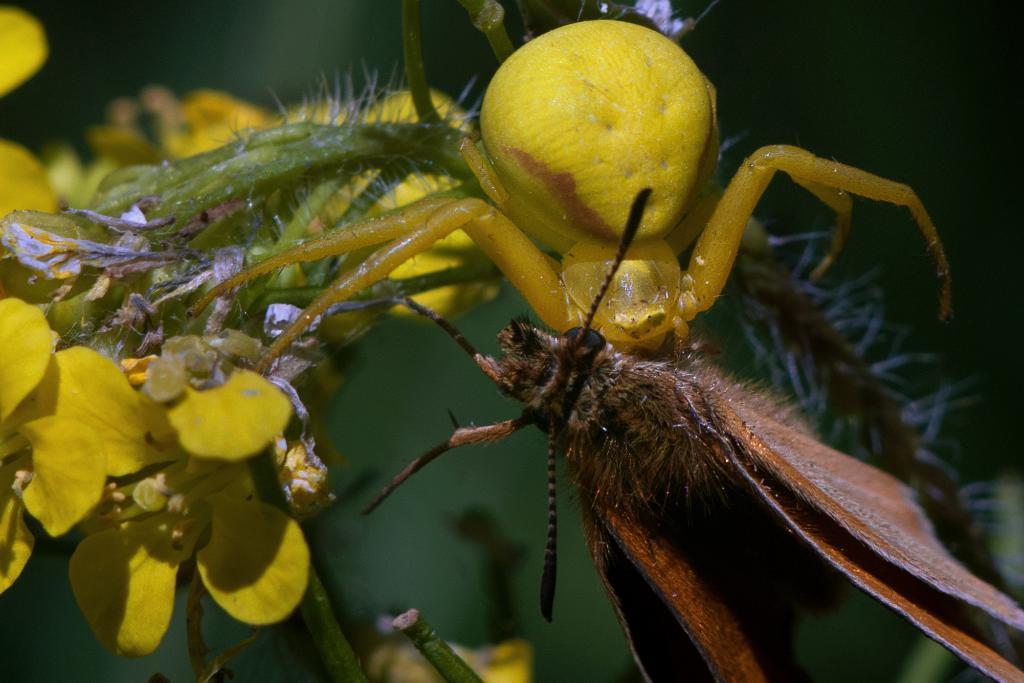Could you give a brief overview of what you see in this image? In this picture there is an yellow color insect and there is a brown color insect on the plant and there are yellow color flowers on the plant. At the back image is blurry. 